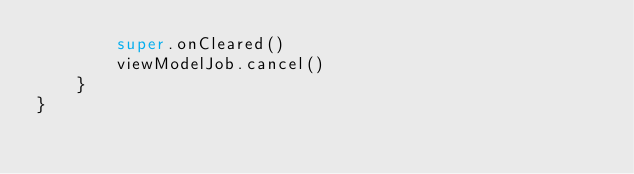Convert code to text. <code><loc_0><loc_0><loc_500><loc_500><_Kotlin_>        super.onCleared()
        viewModelJob.cancel()
    }
}</code> 